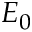<formula> <loc_0><loc_0><loc_500><loc_500>E _ { 0 }</formula> 